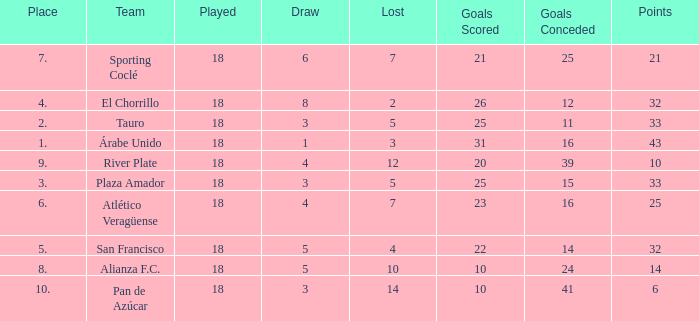How many goals were conceded by the team with more than 21 points more than 5 draws and less than 18 games played? None. Can you give me this table as a dict? {'header': ['Place', 'Team', 'Played', 'Draw', 'Lost', 'Goals Scored', 'Goals Conceded', 'Points'], 'rows': [['7.', 'Sporting Coclé', '18', '6', '7', '21', '25', '21'], ['4.', 'El Chorrillo', '18', '8', '2', '26', '12', '32'], ['2.', 'Tauro', '18', '3', '5', '25', '11', '33'], ['1.', 'Árabe Unido', '18', '1', '3', '31', '16', '43'], ['9.', 'River Plate', '18', '4', '12', '20', '39', '10'], ['3.', 'Plaza Amador', '18', '3', '5', '25', '15', '33'], ['6.', 'Atlético Veragüense', '18', '4', '7', '23', '16', '25'], ['5.', 'San Francisco', '18', '5', '4', '22', '14', '32'], ['8.', 'Alianza F.C.', '18', '5', '10', '10', '24', '14'], ['10.', 'Pan de Azúcar', '18', '3', '14', '10', '41', '6']]} 